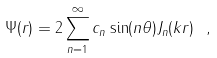<formula> <loc_0><loc_0><loc_500><loc_500>\Psi ( { r } ) = 2 \sum _ { n = 1 } ^ { \infty } c _ { n } \sin ( n \theta ) J _ { n } ( k r ) \ ,</formula> 